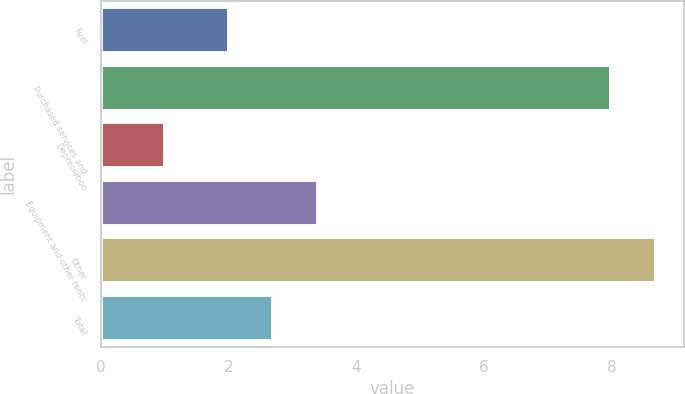Convert chart. <chart><loc_0><loc_0><loc_500><loc_500><bar_chart><fcel>Fuel<fcel>Purchased services and<fcel>Depreciation<fcel>Equipment and other rents<fcel>Other<fcel>Total<nl><fcel>2<fcel>8<fcel>1<fcel>3.4<fcel>8.7<fcel>2.7<nl></chart> 